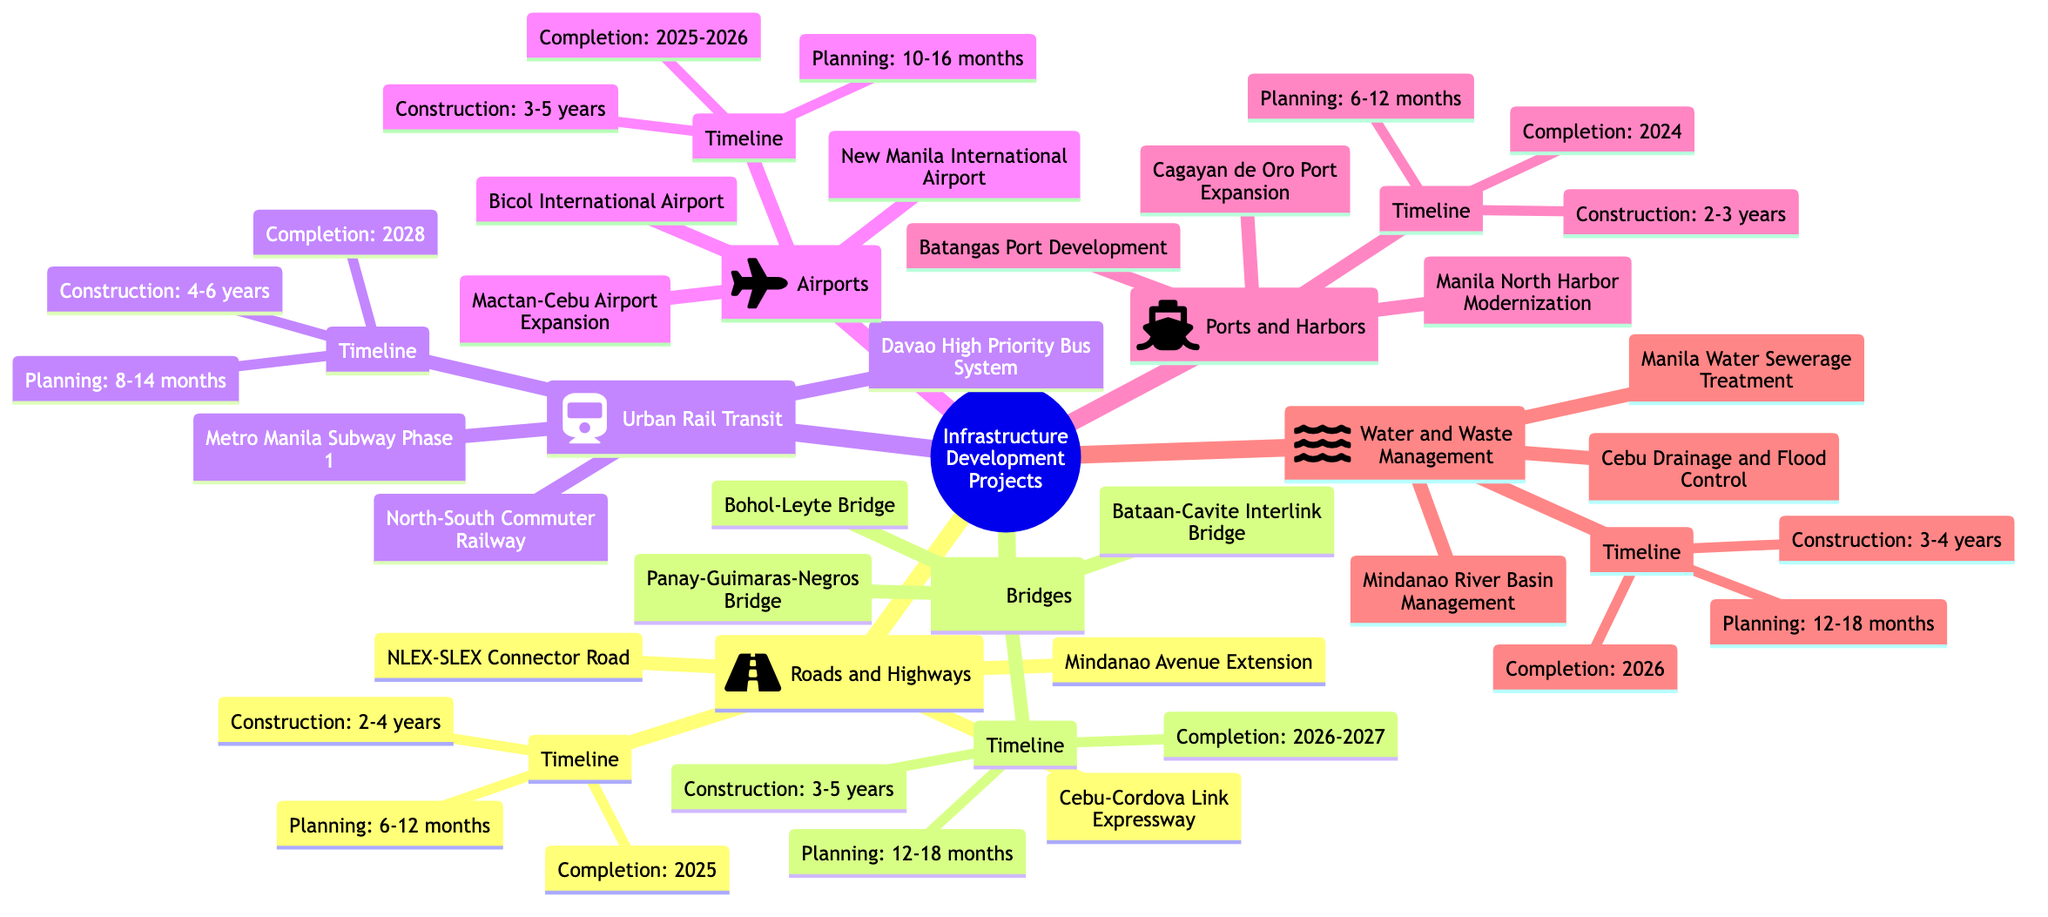What are the completion years for bridge projects? The timeline for the bridge projects is indicated under the "Bridges" section, where it specifies the completion years as "2026-2027."
Answer: 2026-2027 How long is the planning phase for water and waste management projects? Looking at the timeline for "Water and Waste Management," the planning phase is labeled as "12-18 months."
Answer: 12-18 months How many urban rail transit projects are listed? The "Urban Rail Transit" section lists three projects: "Metro Manila Subway Phase 1," "North-South Commuter Railway," and "Davao High Priority Bus System." Therefore, the total number of projects is three.
Answer: 3 What is the construction duration for airports? Under the "Airports" section, the timeline for construction is clearly stated as "3-5 years."
Answer: 3-5 years Which project is expected to complete in 2025? The "Roads and Highways" section indicates that the projects listed, particularly "NLEX-SLEX Connector Road," are planned for completion in "2025."
Answer: 2025 What is the maximum timeline for planning in roads and highways? The timeline for "Roads and Highways" projects indicates a planning phase of "6-12 months," which includes both a minimum and maximum timeframe. Therefore, the maximum is 12 months.
Answer: 12 months Which category includes the Bohol-Leyte Bridge? The "Bohol-Leyte Bridge" project is categorized under "Bridges" in the mind map. This categorization can be verified by reviewing the projects listed in that section.
Answer: Bridges How many categories are represented in the mind map? The mind map outlines a total of six categories: "Roads and Highways," "Bridges," "Urban Rail Transit," "Airports," "Ports and Harbors," and "Water and Waste Management." Hence, the total count is six.
Answer: 6 What is the planned duration for construction in ports and harbors? Within the "Ports and Harbors" timeline, the construction duration is specified as "2-3 years." Thus, it can be concluded that this is the time planned for those projects.
Answer: 2-3 years 